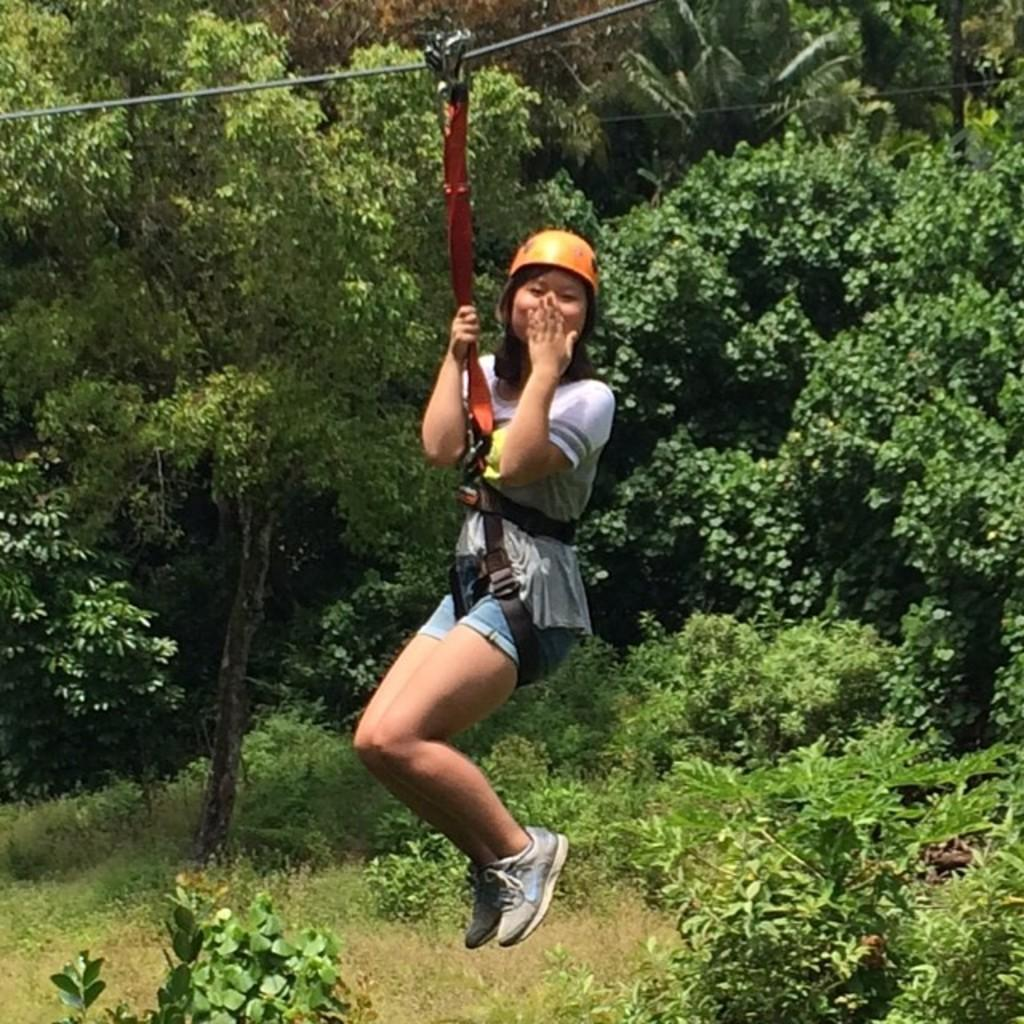Who is the main subject in the image? There is a woman in the image. What is the woman doing in the image? The woman is hanging on a rope and posing for the picture. What safety gear is the woman wearing? The woman is wearing a helmet. What can be seen in the background of the image? There are trees visible in the background of the image. What type of quill is the woman using to write in the image? There is no quill present in the image, and the woman is not writing. Can you tell me if there is a river visible in the image? There is no river visible in the image; only trees can be seen in the background. 